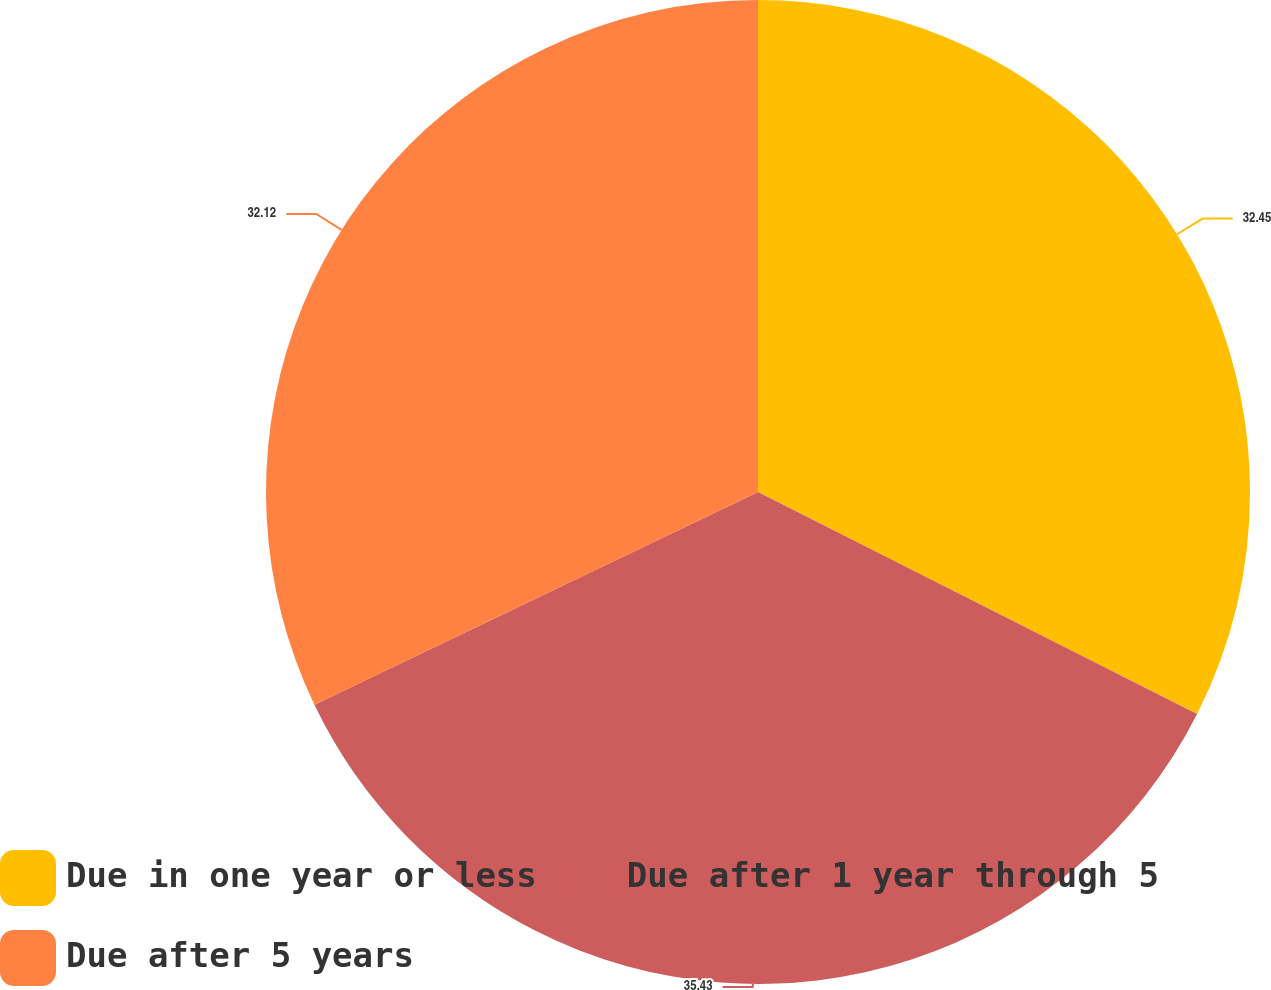Convert chart to OTSL. <chart><loc_0><loc_0><loc_500><loc_500><pie_chart><fcel>Due in one year or less<fcel>Due after 1 year through 5<fcel>Due after 5 years<nl><fcel>32.45%<fcel>35.43%<fcel>32.12%<nl></chart> 